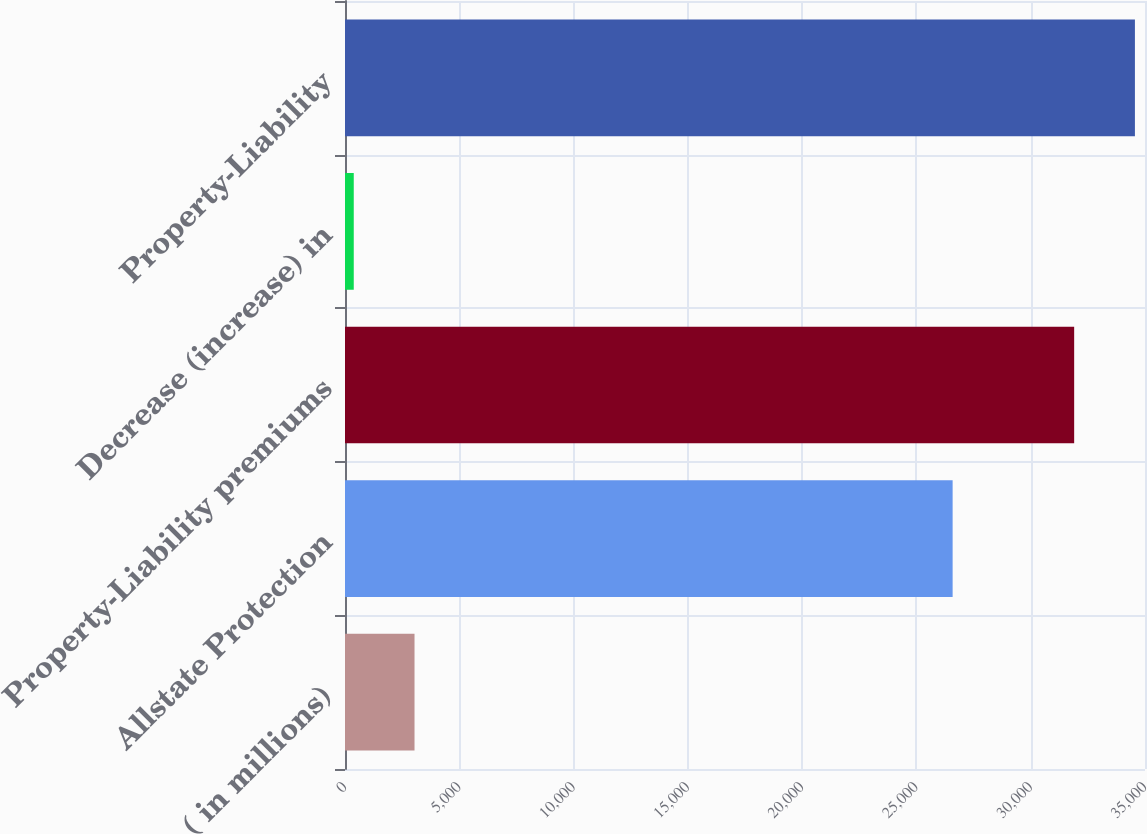Convert chart. <chart><loc_0><loc_0><loc_500><loc_500><bar_chart><fcel>( in millions)<fcel>Allstate Protection<fcel>Property-Liability premiums<fcel>Decrease (increase) in<fcel>Property-Liability<nl><fcel>3041.4<fcel>26584<fcel>31900.8<fcel>383<fcel>34559.2<nl></chart> 